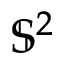Convert formula to latex. <formula><loc_0><loc_0><loc_500><loc_500>\mathbb { S } ^ { 2 }</formula> 